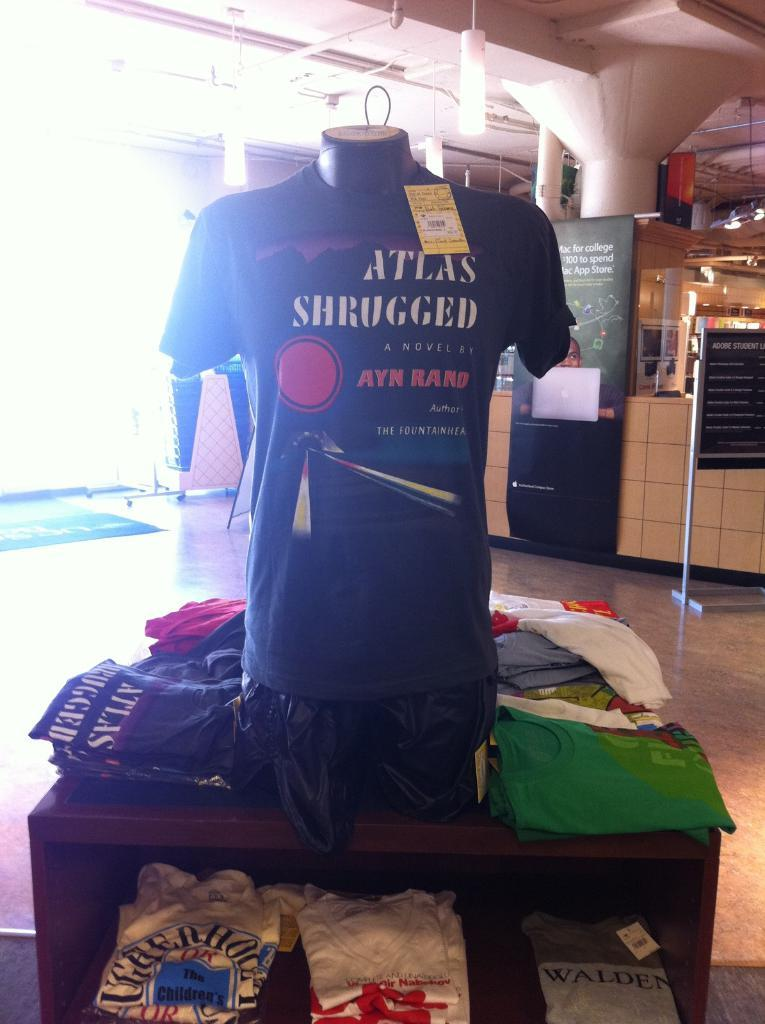<image>
Present a compact description of the photo's key features. Shirt for sale in a store which says "Atlas Shrugged". 